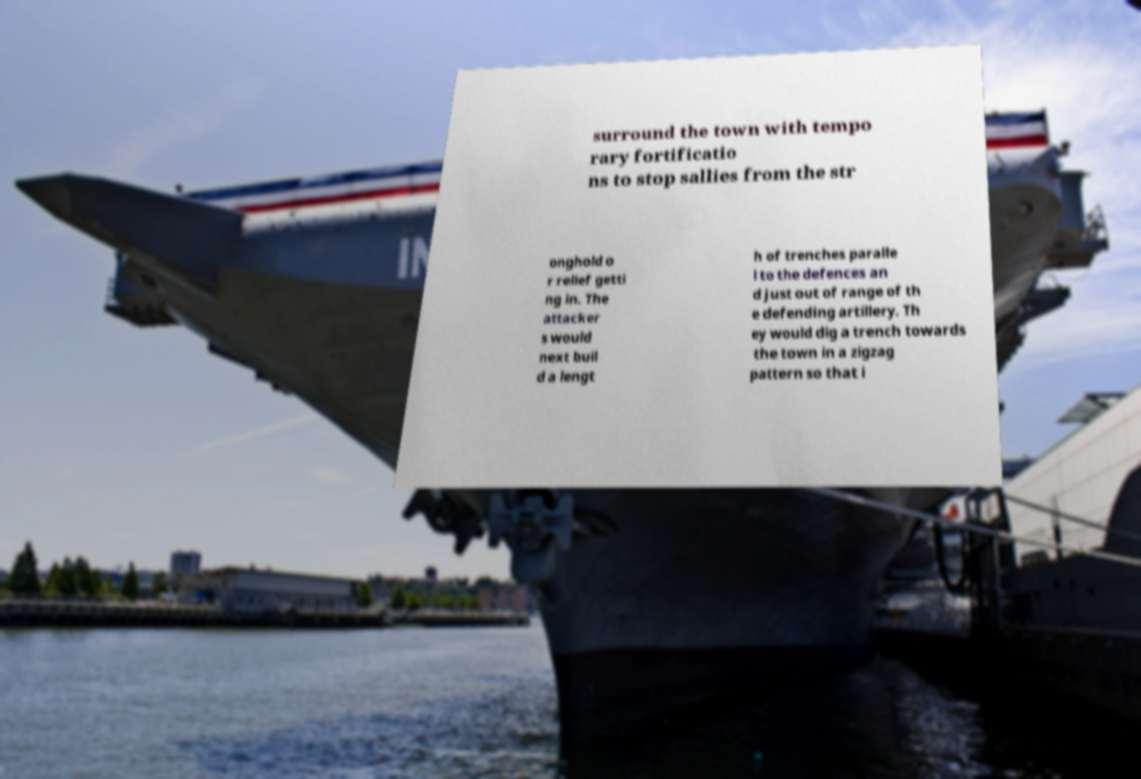Can you read and provide the text displayed in the image?This photo seems to have some interesting text. Can you extract and type it out for me? surround the town with tempo rary fortificatio ns to stop sallies from the str onghold o r relief getti ng in. The attacker s would next buil d a lengt h of trenches paralle l to the defences an d just out of range of th e defending artillery. Th ey would dig a trench towards the town in a zigzag pattern so that i 